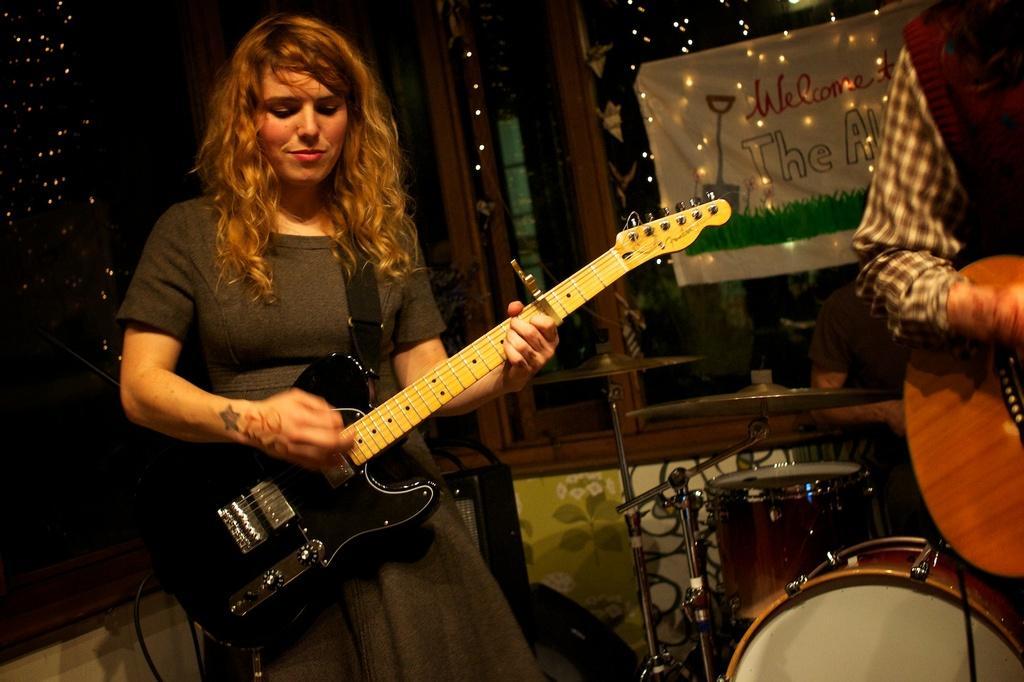Can you describe this image briefly? In this image a lady person wearing black color dress playing guitar. 